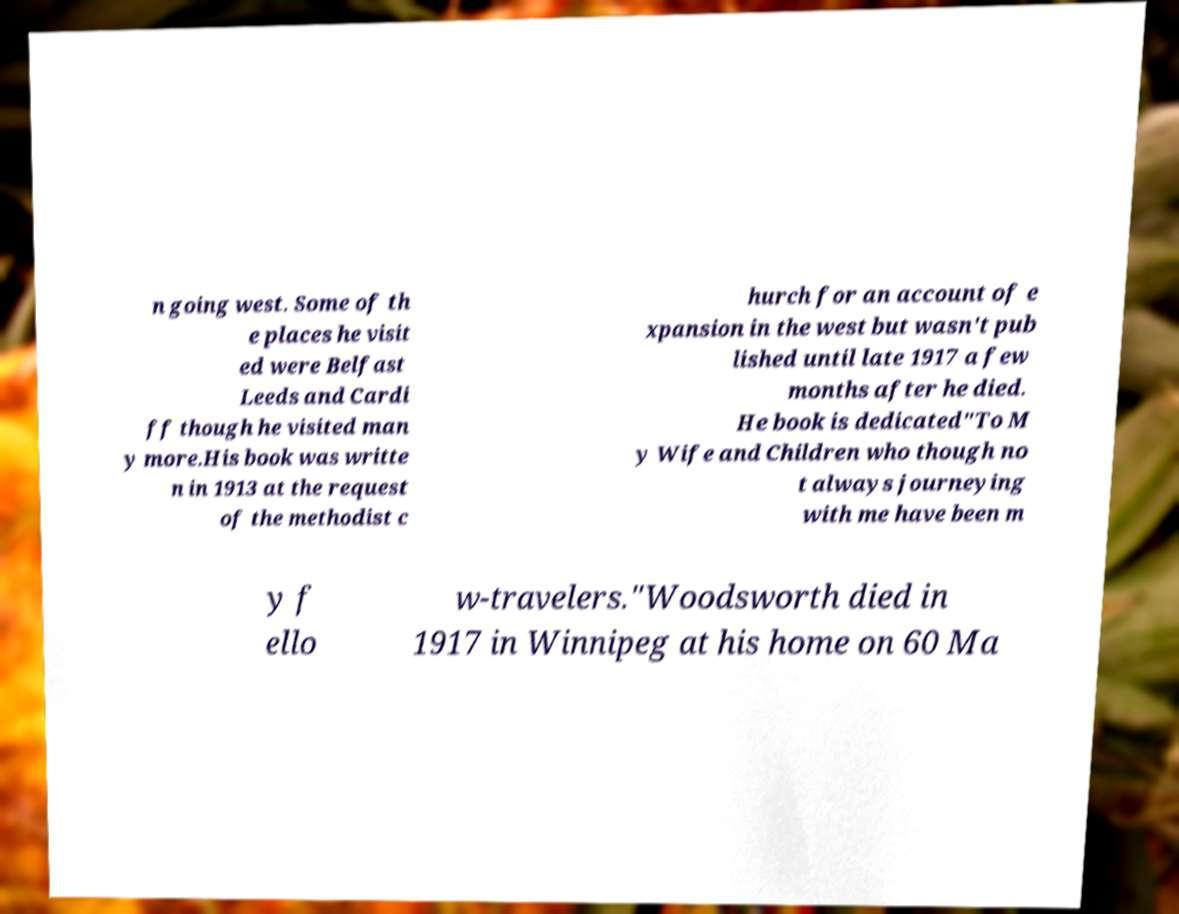What messages or text are displayed in this image? I need them in a readable, typed format. n going west. Some of th e places he visit ed were Belfast Leeds and Cardi ff though he visited man y more.His book was writte n in 1913 at the request of the methodist c hurch for an account of e xpansion in the west but wasn't pub lished until late 1917 a few months after he died. He book is dedicated"To M y Wife and Children who though no t always journeying with me have been m y f ello w-travelers."Woodsworth died in 1917 in Winnipeg at his home on 60 Ma 